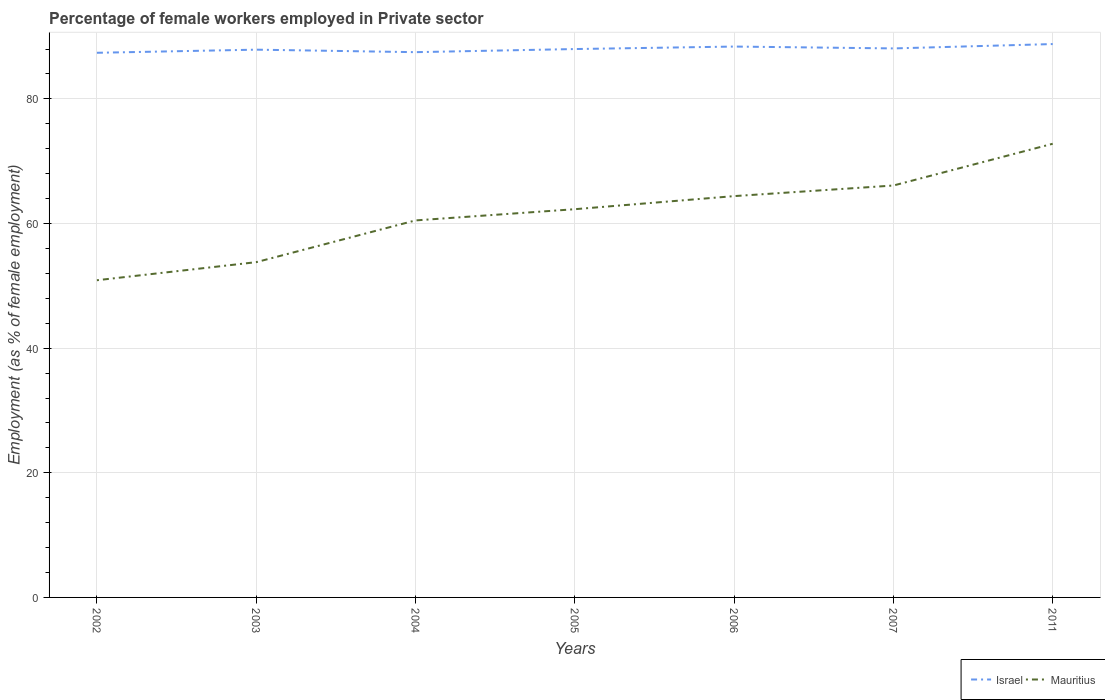Does the line corresponding to Mauritius intersect with the line corresponding to Israel?
Your response must be concise. No. Across all years, what is the maximum percentage of females employed in Private sector in Israel?
Ensure brevity in your answer.  87.4. In which year was the percentage of females employed in Private sector in Mauritius maximum?
Offer a terse response. 2002. What is the total percentage of females employed in Private sector in Mauritius in the graph?
Provide a succinct answer. -3.8. What is the difference between the highest and the second highest percentage of females employed in Private sector in Israel?
Your answer should be very brief. 1.4. What is the difference between the highest and the lowest percentage of females employed in Private sector in Israel?
Ensure brevity in your answer.  3. Is the percentage of females employed in Private sector in Mauritius strictly greater than the percentage of females employed in Private sector in Israel over the years?
Provide a succinct answer. Yes. How many years are there in the graph?
Provide a succinct answer. 7. What is the difference between two consecutive major ticks on the Y-axis?
Give a very brief answer. 20. Does the graph contain any zero values?
Your answer should be very brief. No. Does the graph contain grids?
Offer a very short reply. Yes. How are the legend labels stacked?
Provide a short and direct response. Horizontal. What is the title of the graph?
Make the answer very short. Percentage of female workers employed in Private sector. Does "Heavily indebted poor countries" appear as one of the legend labels in the graph?
Provide a succinct answer. No. What is the label or title of the X-axis?
Provide a succinct answer. Years. What is the label or title of the Y-axis?
Your answer should be compact. Employment (as % of female employment). What is the Employment (as % of female employment) of Israel in 2002?
Your answer should be compact. 87.4. What is the Employment (as % of female employment) in Mauritius in 2002?
Give a very brief answer. 50.9. What is the Employment (as % of female employment) of Israel in 2003?
Give a very brief answer. 87.9. What is the Employment (as % of female employment) of Mauritius in 2003?
Make the answer very short. 53.8. What is the Employment (as % of female employment) of Israel in 2004?
Your response must be concise. 87.5. What is the Employment (as % of female employment) in Mauritius in 2004?
Your answer should be compact. 60.5. What is the Employment (as % of female employment) in Israel in 2005?
Ensure brevity in your answer.  88. What is the Employment (as % of female employment) in Mauritius in 2005?
Give a very brief answer. 62.3. What is the Employment (as % of female employment) in Israel in 2006?
Offer a very short reply. 88.4. What is the Employment (as % of female employment) of Mauritius in 2006?
Offer a very short reply. 64.4. What is the Employment (as % of female employment) of Israel in 2007?
Provide a short and direct response. 88.1. What is the Employment (as % of female employment) of Mauritius in 2007?
Your answer should be very brief. 66.1. What is the Employment (as % of female employment) of Israel in 2011?
Ensure brevity in your answer.  88.8. What is the Employment (as % of female employment) of Mauritius in 2011?
Your answer should be very brief. 72.8. Across all years, what is the maximum Employment (as % of female employment) in Israel?
Provide a succinct answer. 88.8. Across all years, what is the maximum Employment (as % of female employment) of Mauritius?
Ensure brevity in your answer.  72.8. Across all years, what is the minimum Employment (as % of female employment) of Israel?
Give a very brief answer. 87.4. Across all years, what is the minimum Employment (as % of female employment) in Mauritius?
Ensure brevity in your answer.  50.9. What is the total Employment (as % of female employment) of Israel in the graph?
Your answer should be compact. 616.1. What is the total Employment (as % of female employment) of Mauritius in the graph?
Ensure brevity in your answer.  430.8. What is the difference between the Employment (as % of female employment) in Mauritius in 2002 and that in 2003?
Provide a succinct answer. -2.9. What is the difference between the Employment (as % of female employment) in Israel in 2002 and that in 2004?
Your response must be concise. -0.1. What is the difference between the Employment (as % of female employment) of Mauritius in 2002 and that in 2005?
Your answer should be compact. -11.4. What is the difference between the Employment (as % of female employment) in Mauritius in 2002 and that in 2006?
Provide a short and direct response. -13.5. What is the difference between the Employment (as % of female employment) in Mauritius in 2002 and that in 2007?
Ensure brevity in your answer.  -15.2. What is the difference between the Employment (as % of female employment) of Israel in 2002 and that in 2011?
Make the answer very short. -1.4. What is the difference between the Employment (as % of female employment) in Mauritius in 2002 and that in 2011?
Give a very brief answer. -21.9. What is the difference between the Employment (as % of female employment) in Israel in 2003 and that in 2004?
Your answer should be very brief. 0.4. What is the difference between the Employment (as % of female employment) in Mauritius in 2003 and that in 2006?
Make the answer very short. -10.6. What is the difference between the Employment (as % of female employment) of Israel in 2003 and that in 2007?
Give a very brief answer. -0.2. What is the difference between the Employment (as % of female employment) of Israel in 2004 and that in 2005?
Provide a short and direct response. -0.5. What is the difference between the Employment (as % of female employment) of Mauritius in 2004 and that in 2005?
Your answer should be compact. -1.8. What is the difference between the Employment (as % of female employment) of Israel in 2004 and that in 2006?
Your answer should be compact. -0.9. What is the difference between the Employment (as % of female employment) of Mauritius in 2004 and that in 2006?
Offer a terse response. -3.9. What is the difference between the Employment (as % of female employment) in Israel in 2004 and that in 2007?
Offer a terse response. -0.6. What is the difference between the Employment (as % of female employment) of Israel in 2004 and that in 2011?
Offer a very short reply. -1.3. What is the difference between the Employment (as % of female employment) in Mauritius in 2004 and that in 2011?
Keep it short and to the point. -12.3. What is the difference between the Employment (as % of female employment) in Israel in 2005 and that in 2006?
Keep it short and to the point. -0.4. What is the difference between the Employment (as % of female employment) in Mauritius in 2005 and that in 2006?
Your response must be concise. -2.1. What is the difference between the Employment (as % of female employment) of Mauritius in 2005 and that in 2007?
Provide a succinct answer. -3.8. What is the difference between the Employment (as % of female employment) of Israel in 2005 and that in 2011?
Provide a succinct answer. -0.8. What is the difference between the Employment (as % of female employment) in Mauritius in 2005 and that in 2011?
Offer a very short reply. -10.5. What is the difference between the Employment (as % of female employment) in Israel in 2006 and that in 2007?
Offer a very short reply. 0.3. What is the difference between the Employment (as % of female employment) in Israel in 2002 and the Employment (as % of female employment) in Mauritius in 2003?
Offer a very short reply. 33.6. What is the difference between the Employment (as % of female employment) of Israel in 2002 and the Employment (as % of female employment) of Mauritius in 2004?
Your answer should be very brief. 26.9. What is the difference between the Employment (as % of female employment) of Israel in 2002 and the Employment (as % of female employment) of Mauritius in 2005?
Provide a short and direct response. 25.1. What is the difference between the Employment (as % of female employment) in Israel in 2002 and the Employment (as % of female employment) in Mauritius in 2006?
Keep it short and to the point. 23. What is the difference between the Employment (as % of female employment) of Israel in 2002 and the Employment (as % of female employment) of Mauritius in 2007?
Provide a succinct answer. 21.3. What is the difference between the Employment (as % of female employment) in Israel in 2002 and the Employment (as % of female employment) in Mauritius in 2011?
Provide a succinct answer. 14.6. What is the difference between the Employment (as % of female employment) of Israel in 2003 and the Employment (as % of female employment) of Mauritius in 2004?
Give a very brief answer. 27.4. What is the difference between the Employment (as % of female employment) of Israel in 2003 and the Employment (as % of female employment) of Mauritius in 2005?
Your answer should be compact. 25.6. What is the difference between the Employment (as % of female employment) of Israel in 2003 and the Employment (as % of female employment) of Mauritius in 2007?
Make the answer very short. 21.8. What is the difference between the Employment (as % of female employment) of Israel in 2004 and the Employment (as % of female employment) of Mauritius in 2005?
Offer a terse response. 25.2. What is the difference between the Employment (as % of female employment) of Israel in 2004 and the Employment (as % of female employment) of Mauritius in 2006?
Your answer should be very brief. 23.1. What is the difference between the Employment (as % of female employment) in Israel in 2004 and the Employment (as % of female employment) in Mauritius in 2007?
Provide a short and direct response. 21.4. What is the difference between the Employment (as % of female employment) in Israel in 2004 and the Employment (as % of female employment) in Mauritius in 2011?
Your response must be concise. 14.7. What is the difference between the Employment (as % of female employment) of Israel in 2005 and the Employment (as % of female employment) of Mauritius in 2006?
Offer a terse response. 23.6. What is the difference between the Employment (as % of female employment) of Israel in 2005 and the Employment (as % of female employment) of Mauritius in 2007?
Your answer should be very brief. 21.9. What is the difference between the Employment (as % of female employment) in Israel in 2005 and the Employment (as % of female employment) in Mauritius in 2011?
Your answer should be compact. 15.2. What is the difference between the Employment (as % of female employment) in Israel in 2006 and the Employment (as % of female employment) in Mauritius in 2007?
Make the answer very short. 22.3. What is the difference between the Employment (as % of female employment) of Israel in 2006 and the Employment (as % of female employment) of Mauritius in 2011?
Ensure brevity in your answer.  15.6. What is the difference between the Employment (as % of female employment) in Israel in 2007 and the Employment (as % of female employment) in Mauritius in 2011?
Your answer should be very brief. 15.3. What is the average Employment (as % of female employment) of Israel per year?
Make the answer very short. 88.01. What is the average Employment (as % of female employment) of Mauritius per year?
Keep it short and to the point. 61.54. In the year 2002, what is the difference between the Employment (as % of female employment) in Israel and Employment (as % of female employment) in Mauritius?
Provide a succinct answer. 36.5. In the year 2003, what is the difference between the Employment (as % of female employment) in Israel and Employment (as % of female employment) in Mauritius?
Your response must be concise. 34.1. In the year 2004, what is the difference between the Employment (as % of female employment) of Israel and Employment (as % of female employment) of Mauritius?
Keep it short and to the point. 27. In the year 2005, what is the difference between the Employment (as % of female employment) of Israel and Employment (as % of female employment) of Mauritius?
Give a very brief answer. 25.7. What is the ratio of the Employment (as % of female employment) of Israel in 2002 to that in 2003?
Make the answer very short. 0.99. What is the ratio of the Employment (as % of female employment) in Mauritius in 2002 to that in 2003?
Offer a terse response. 0.95. What is the ratio of the Employment (as % of female employment) of Mauritius in 2002 to that in 2004?
Ensure brevity in your answer.  0.84. What is the ratio of the Employment (as % of female employment) of Israel in 2002 to that in 2005?
Offer a terse response. 0.99. What is the ratio of the Employment (as % of female employment) of Mauritius in 2002 to that in 2005?
Provide a succinct answer. 0.82. What is the ratio of the Employment (as % of female employment) of Israel in 2002 to that in 2006?
Your response must be concise. 0.99. What is the ratio of the Employment (as % of female employment) in Mauritius in 2002 to that in 2006?
Offer a very short reply. 0.79. What is the ratio of the Employment (as % of female employment) of Israel in 2002 to that in 2007?
Offer a terse response. 0.99. What is the ratio of the Employment (as % of female employment) in Mauritius in 2002 to that in 2007?
Provide a succinct answer. 0.77. What is the ratio of the Employment (as % of female employment) of Israel in 2002 to that in 2011?
Provide a short and direct response. 0.98. What is the ratio of the Employment (as % of female employment) in Mauritius in 2002 to that in 2011?
Your response must be concise. 0.7. What is the ratio of the Employment (as % of female employment) of Mauritius in 2003 to that in 2004?
Offer a terse response. 0.89. What is the ratio of the Employment (as % of female employment) of Israel in 2003 to that in 2005?
Give a very brief answer. 1. What is the ratio of the Employment (as % of female employment) in Mauritius in 2003 to that in 2005?
Keep it short and to the point. 0.86. What is the ratio of the Employment (as % of female employment) of Israel in 2003 to that in 2006?
Your response must be concise. 0.99. What is the ratio of the Employment (as % of female employment) in Mauritius in 2003 to that in 2006?
Your response must be concise. 0.84. What is the ratio of the Employment (as % of female employment) in Israel in 2003 to that in 2007?
Provide a short and direct response. 1. What is the ratio of the Employment (as % of female employment) of Mauritius in 2003 to that in 2007?
Ensure brevity in your answer.  0.81. What is the ratio of the Employment (as % of female employment) of Israel in 2003 to that in 2011?
Provide a succinct answer. 0.99. What is the ratio of the Employment (as % of female employment) of Mauritius in 2003 to that in 2011?
Your answer should be compact. 0.74. What is the ratio of the Employment (as % of female employment) of Israel in 2004 to that in 2005?
Keep it short and to the point. 0.99. What is the ratio of the Employment (as % of female employment) of Mauritius in 2004 to that in 2005?
Make the answer very short. 0.97. What is the ratio of the Employment (as % of female employment) in Israel in 2004 to that in 2006?
Offer a terse response. 0.99. What is the ratio of the Employment (as % of female employment) in Mauritius in 2004 to that in 2006?
Provide a succinct answer. 0.94. What is the ratio of the Employment (as % of female employment) of Mauritius in 2004 to that in 2007?
Your answer should be very brief. 0.92. What is the ratio of the Employment (as % of female employment) of Israel in 2004 to that in 2011?
Ensure brevity in your answer.  0.99. What is the ratio of the Employment (as % of female employment) in Mauritius in 2004 to that in 2011?
Your response must be concise. 0.83. What is the ratio of the Employment (as % of female employment) in Mauritius in 2005 to that in 2006?
Your response must be concise. 0.97. What is the ratio of the Employment (as % of female employment) in Israel in 2005 to that in 2007?
Make the answer very short. 1. What is the ratio of the Employment (as % of female employment) in Mauritius in 2005 to that in 2007?
Give a very brief answer. 0.94. What is the ratio of the Employment (as % of female employment) of Israel in 2005 to that in 2011?
Give a very brief answer. 0.99. What is the ratio of the Employment (as % of female employment) in Mauritius in 2005 to that in 2011?
Offer a very short reply. 0.86. What is the ratio of the Employment (as % of female employment) in Mauritius in 2006 to that in 2007?
Offer a terse response. 0.97. What is the ratio of the Employment (as % of female employment) in Israel in 2006 to that in 2011?
Ensure brevity in your answer.  1. What is the ratio of the Employment (as % of female employment) in Mauritius in 2006 to that in 2011?
Give a very brief answer. 0.88. What is the ratio of the Employment (as % of female employment) in Israel in 2007 to that in 2011?
Ensure brevity in your answer.  0.99. What is the ratio of the Employment (as % of female employment) in Mauritius in 2007 to that in 2011?
Offer a terse response. 0.91. What is the difference between the highest and the lowest Employment (as % of female employment) of Mauritius?
Your response must be concise. 21.9. 